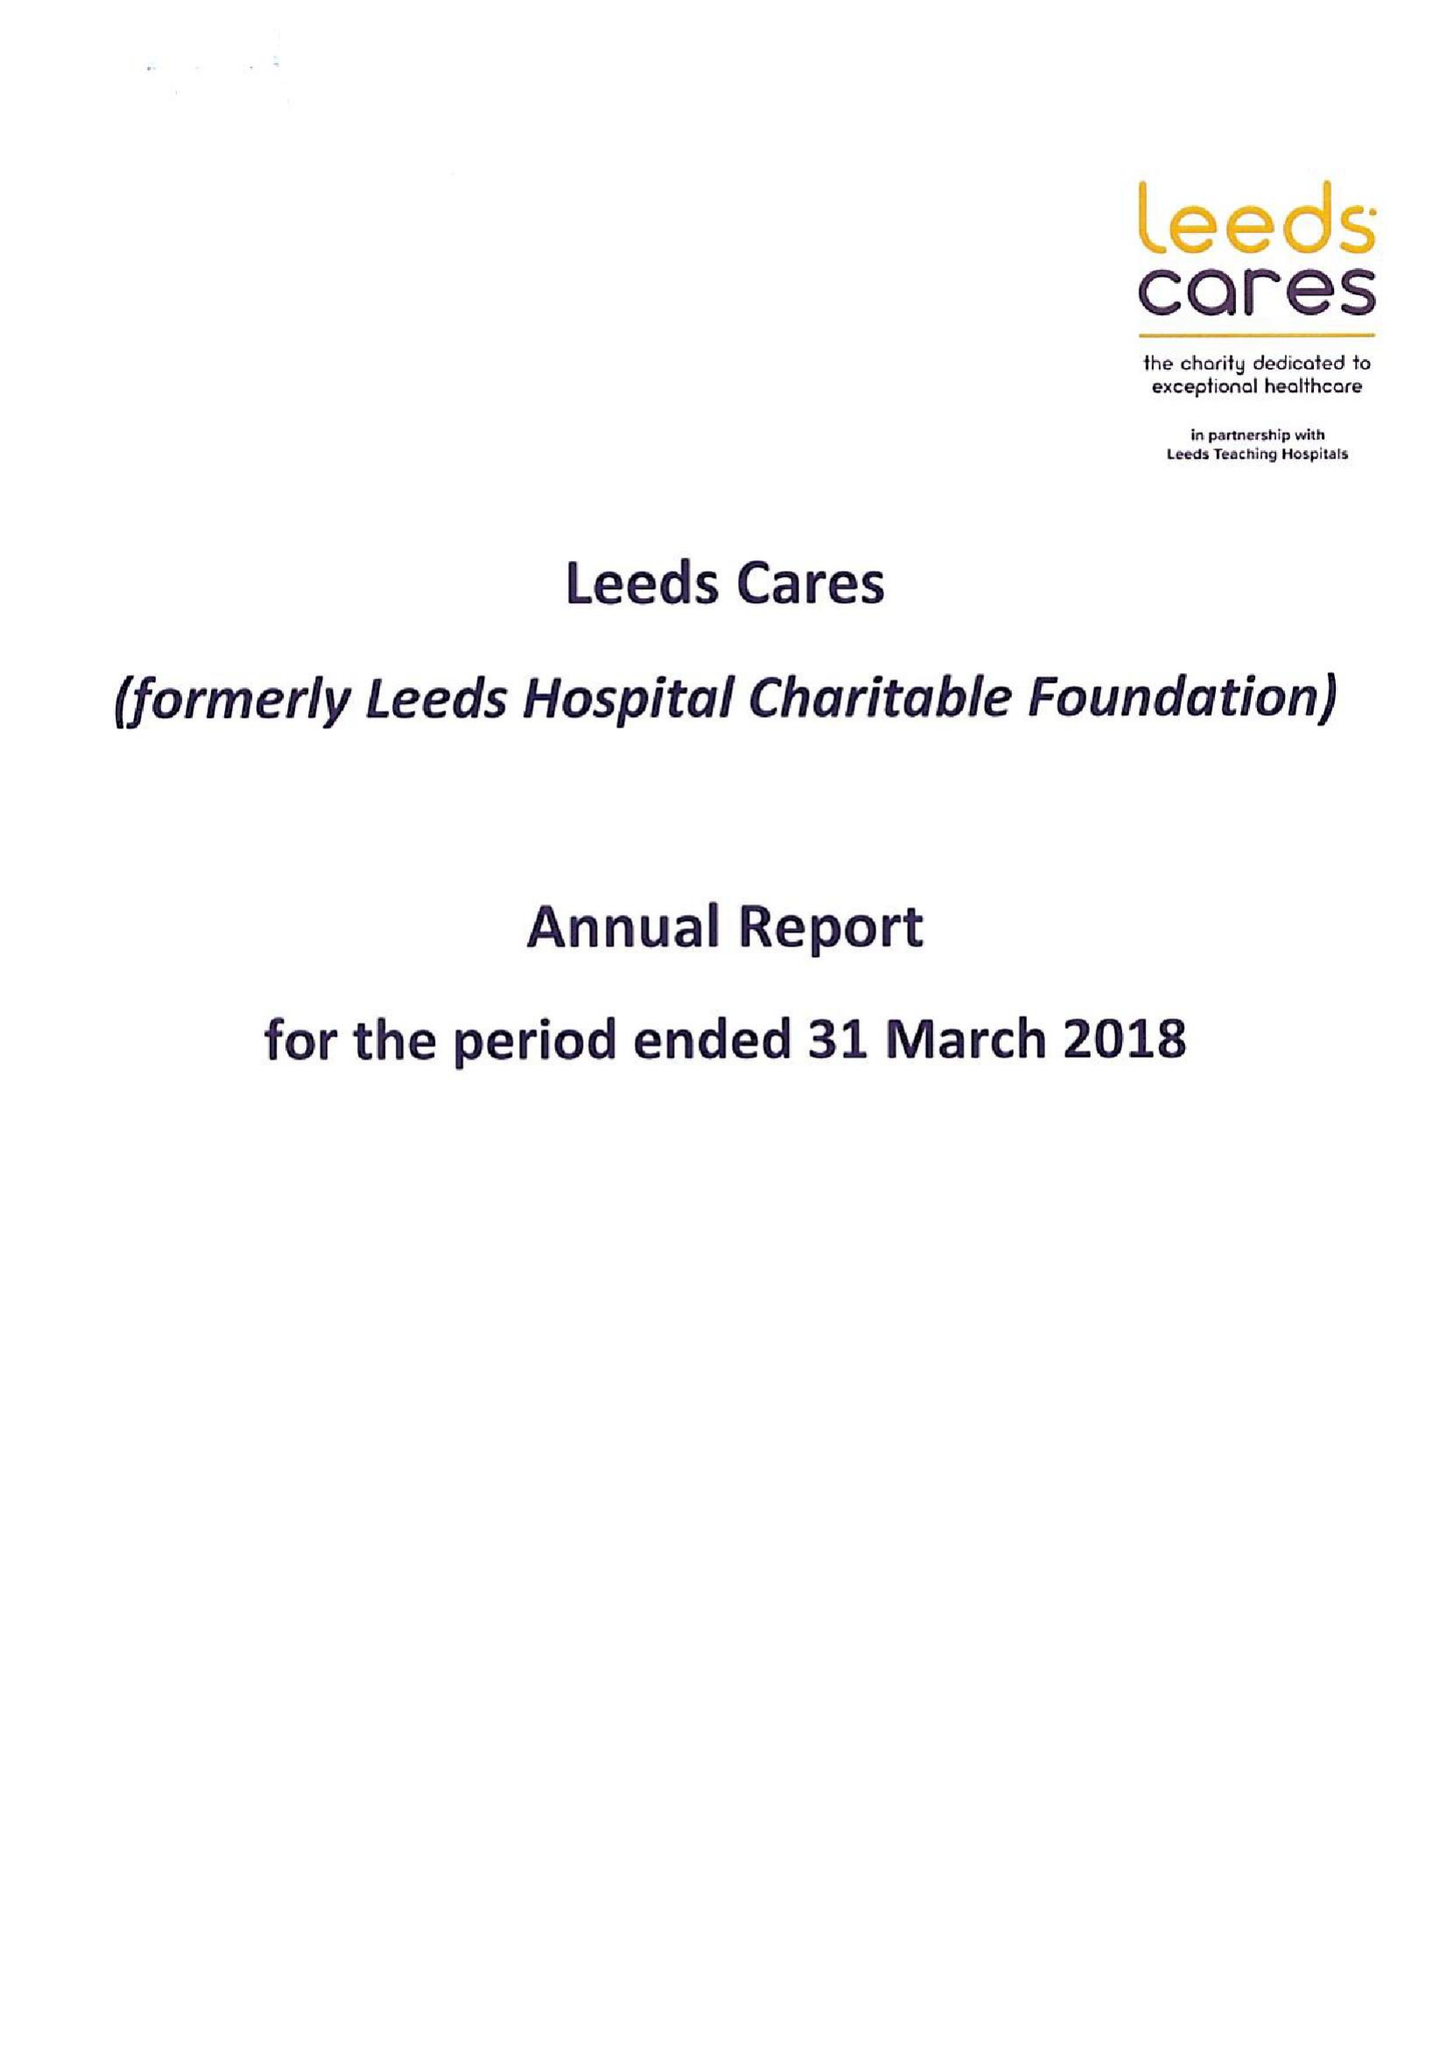What is the value for the address__street_line?
Answer the question using a single word or phrase. BECKETT STREET 